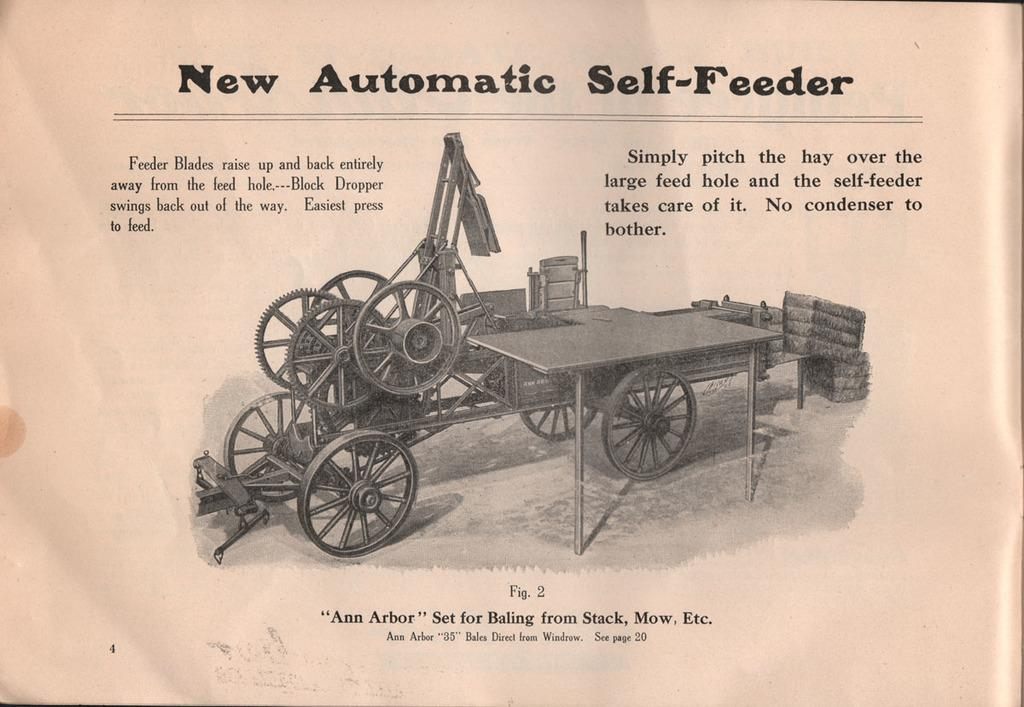What is present on the paper in the image? There is a paper in the image, and it contains words, numbers, and a picture. Can you describe the content of the paper in more detail? The paper has words, numbers, and a picture on it. What type of toothbrush is shown in the image? There is no toothbrush present in the image. What genre of writing is depicted in the image? The image does not show any specific genre of writing, as it only displays words, numbers, and a picture on the paper. 